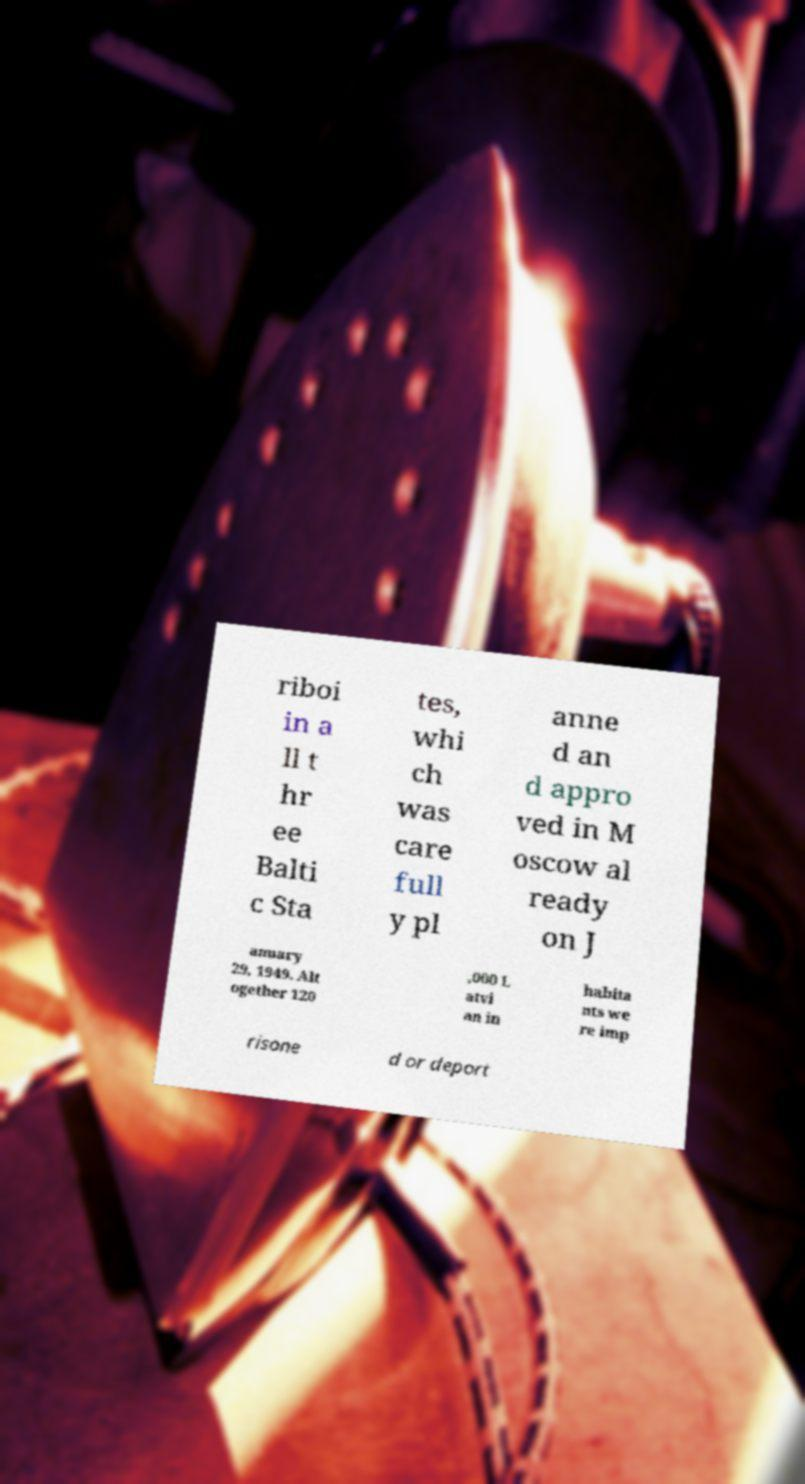For documentation purposes, I need the text within this image transcribed. Could you provide that? riboi in a ll t hr ee Balti c Sta tes, whi ch was care full y pl anne d an d appro ved in M oscow al ready on J anuary 29, 1949. Alt ogether 120 ,000 L atvi an in habita nts we re imp risone d or deport 